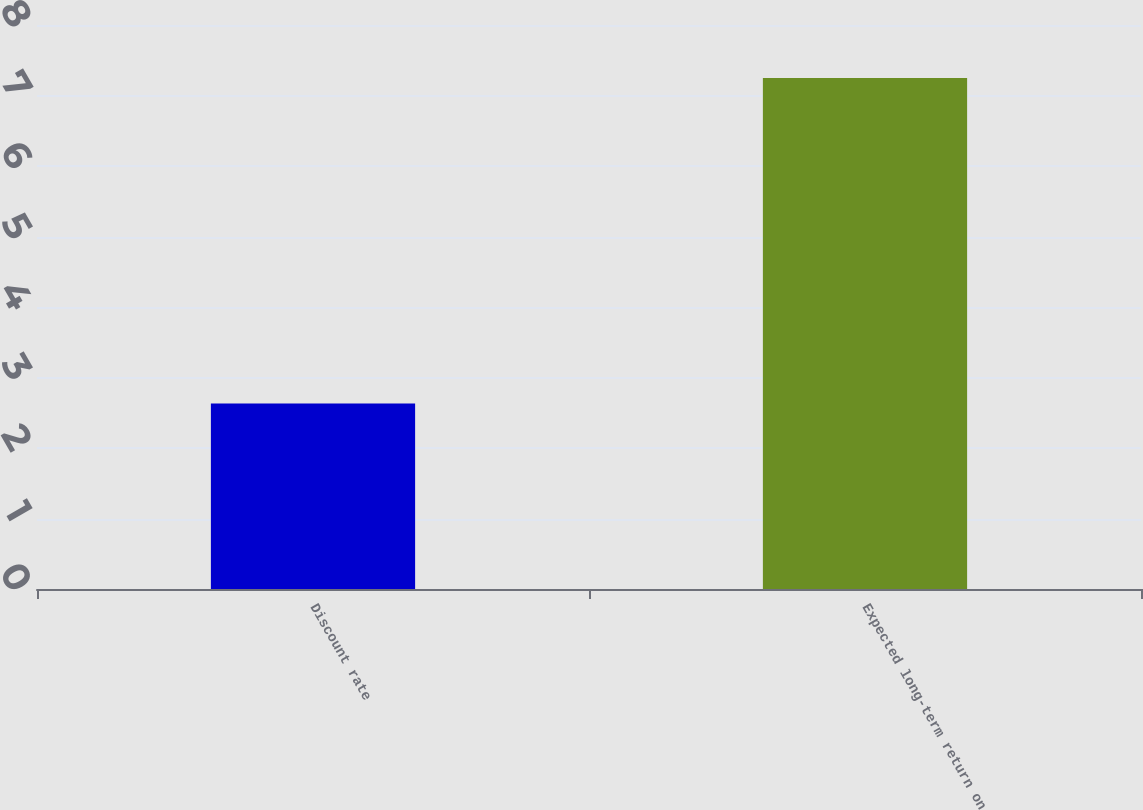Convert chart to OTSL. <chart><loc_0><loc_0><loc_500><loc_500><bar_chart><fcel>Discount rate<fcel>Expected long-term return on<nl><fcel>2.63<fcel>7.25<nl></chart> 